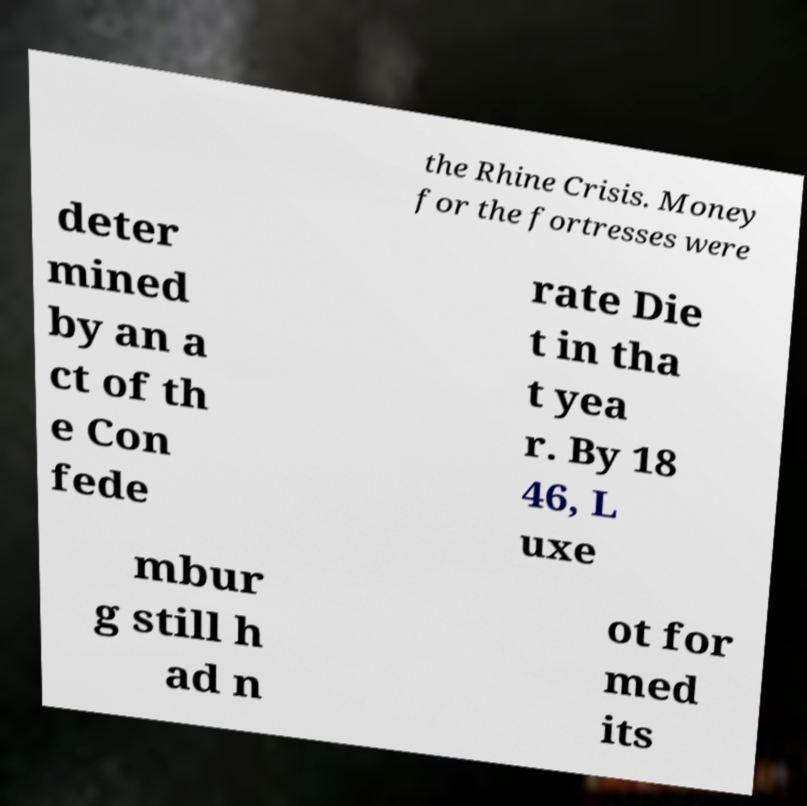I need the written content from this picture converted into text. Can you do that? the Rhine Crisis. Money for the fortresses were deter mined by an a ct of th e Con fede rate Die t in tha t yea r. By 18 46, L uxe mbur g still h ad n ot for med its 